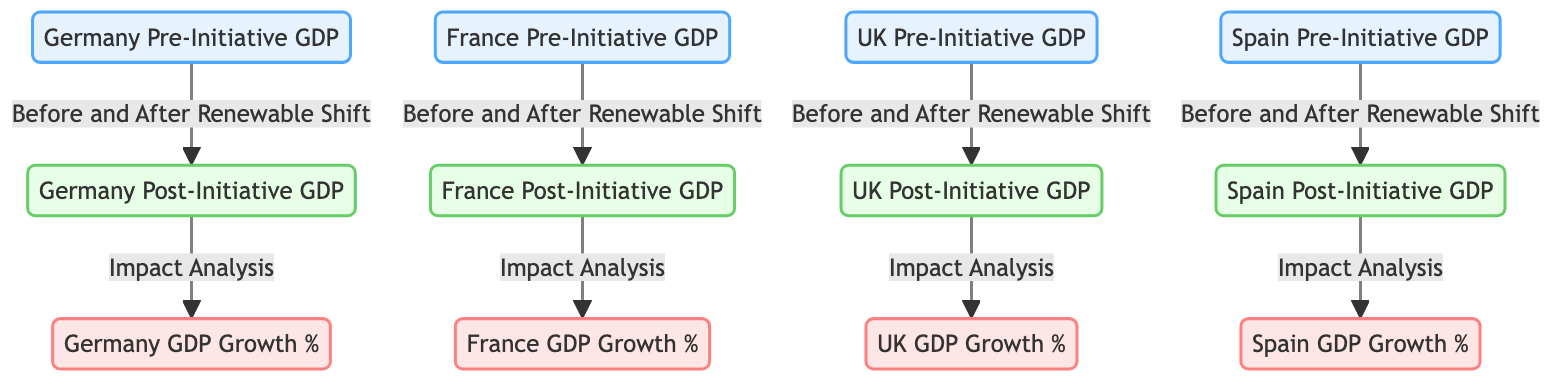What are the nodes representing Germany's GDP before the initiative? The diagram showcases the node labeled "Germany Pre-Initiative GDP," which is the sole representation of Germany's GDP prior to the implementation of renewable energy initiatives.
Answer: Germany Pre-Initiative GDP How many countries' GDPs are represented in this diagram? The diagram includes four countries: Germany, France, the UK, and Spain. Each country has nodes for both pre- and post-initiative GDP, leading to a total of eight nodes related to GDP.
Answer: Four What does the arrow between Germany_Pre and Germany_Post signify? The arrow indicates the relationship of progression from Germany's GDP before the renewable energy initiative (Germany_Pre) to after it (Germany_Post), suggesting an evaluation of the initiative’s impact.
Answer: Impact of the renewable shift Which country has the first node for GDP growth after the initiative? The first GDP growth node displayed after implementation is "Germany GDP Growth %," which directly follows the post-initiative GDP node for Germany, indicating the order in the flow.
Answer: Germany What is the significance of the "Impact Analysis" label associated with each post-initiative GDP node? The "Impact Analysis" label implies that after each country's GDP post-initiative (France_Post, UK_Post, etc.), there is an evaluation or assessment being carried out to analyze the effect of renewable energy implementation on GDP growth, bridging the post-initiative GDP with its economic consequence.
Answer: Evaluates economic impact Which country's GDP post-initiative has the highest growth percentage? While the diagram does not provide specific numbers, it allows for the observation that each country's GDP growth is analyzed separately, with no numerical data to indicate which has the highest growth percentage. However, assuming data is provided elsewhere, the question seeks comparative analysis among the four nations.
Answer: Data not provided in diagram How many total arrows connect pre-initiative and post-initiative nodes in the diagram? Each of the four countries has an arrow connecting the pre-initiative GDP to the post-initiative GDP, resulting in four arrows in total throughout the entire diagram.
Answer: Four arrows 